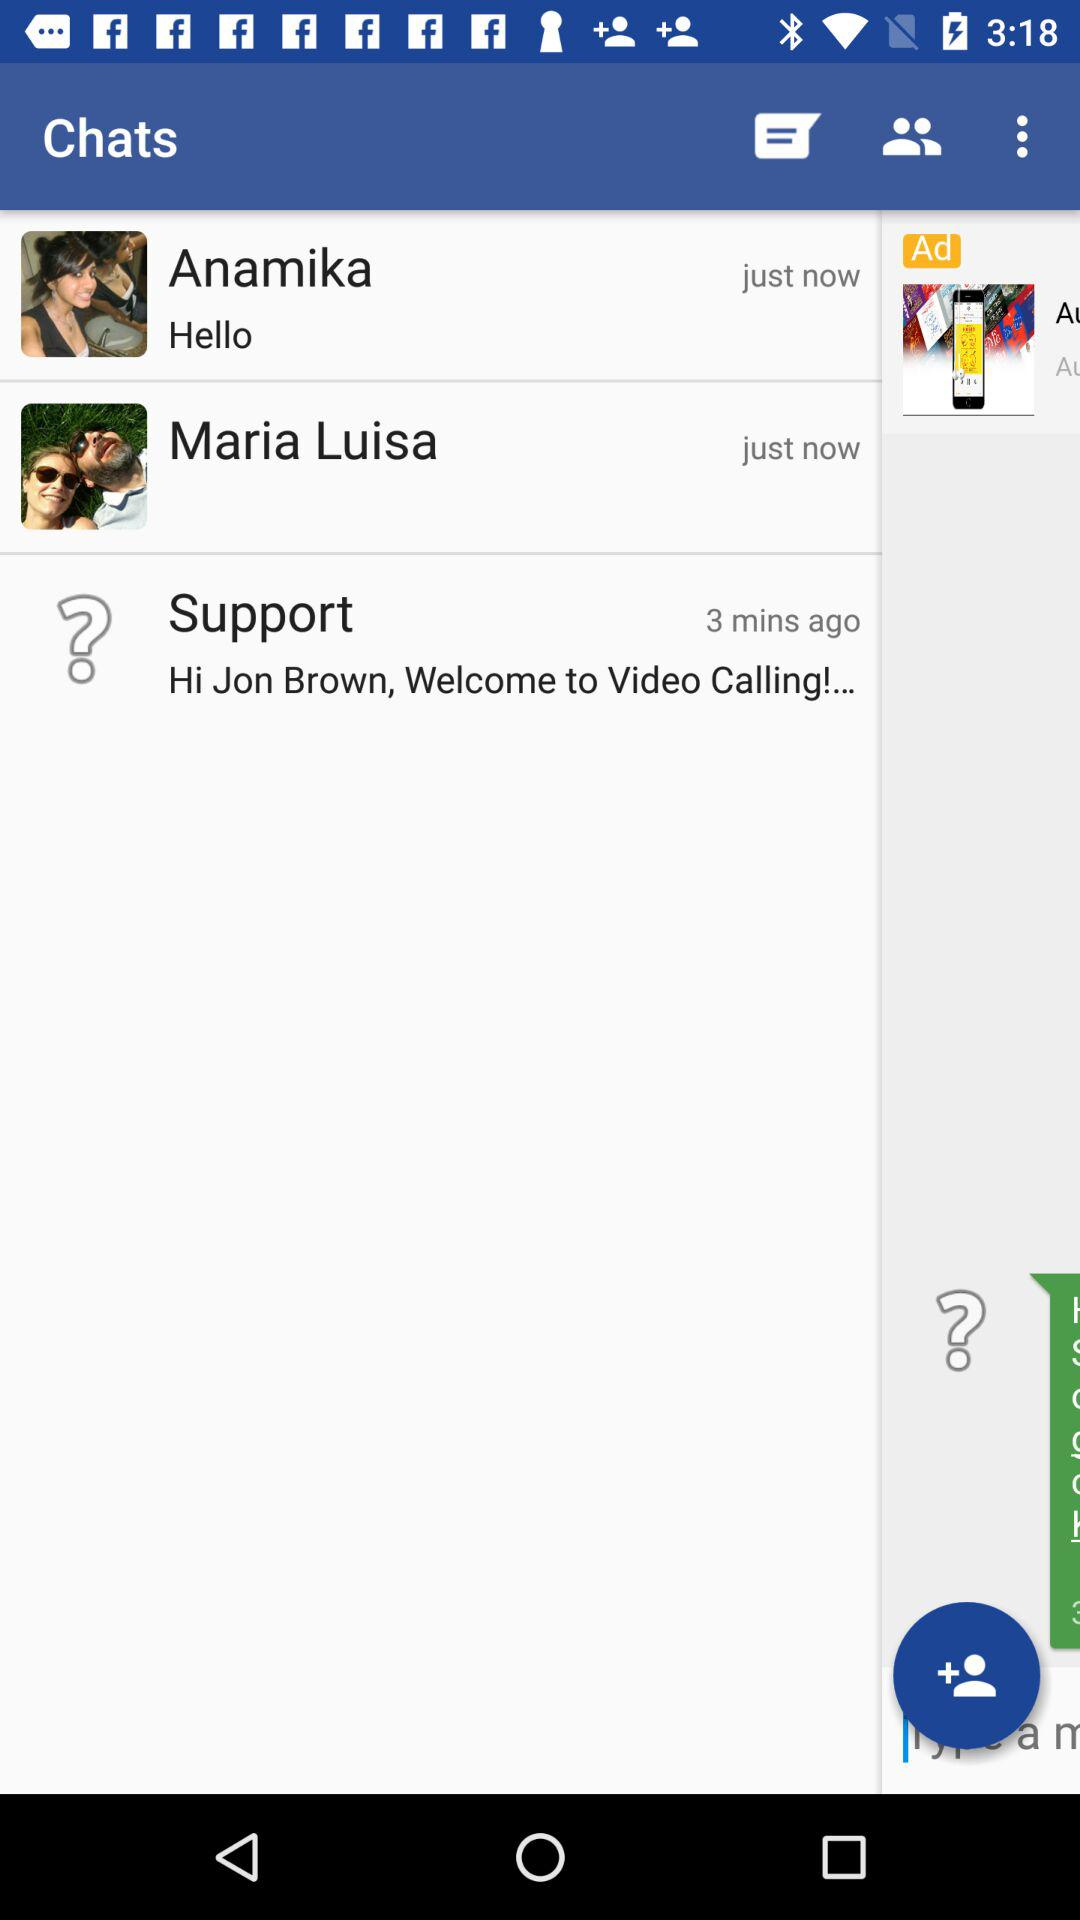What is the message from Anamika? The message is "Hello". 